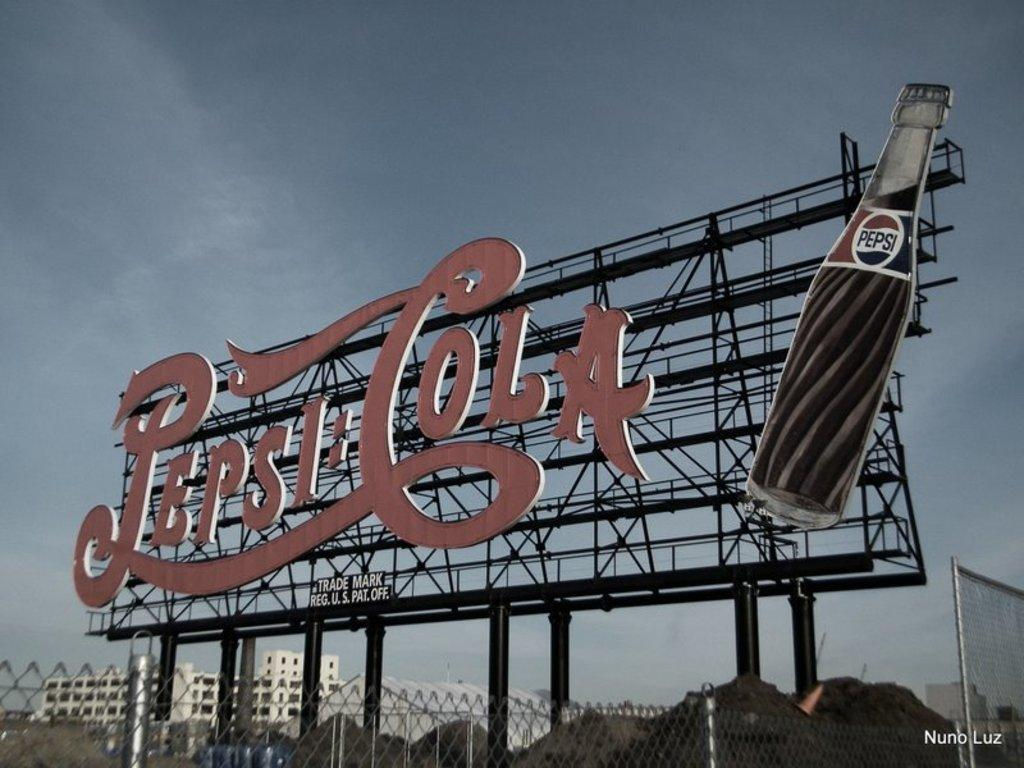<image>
Describe the image concisely. A large sign with a backdrop of the sky that reads Pepsi Cola. 